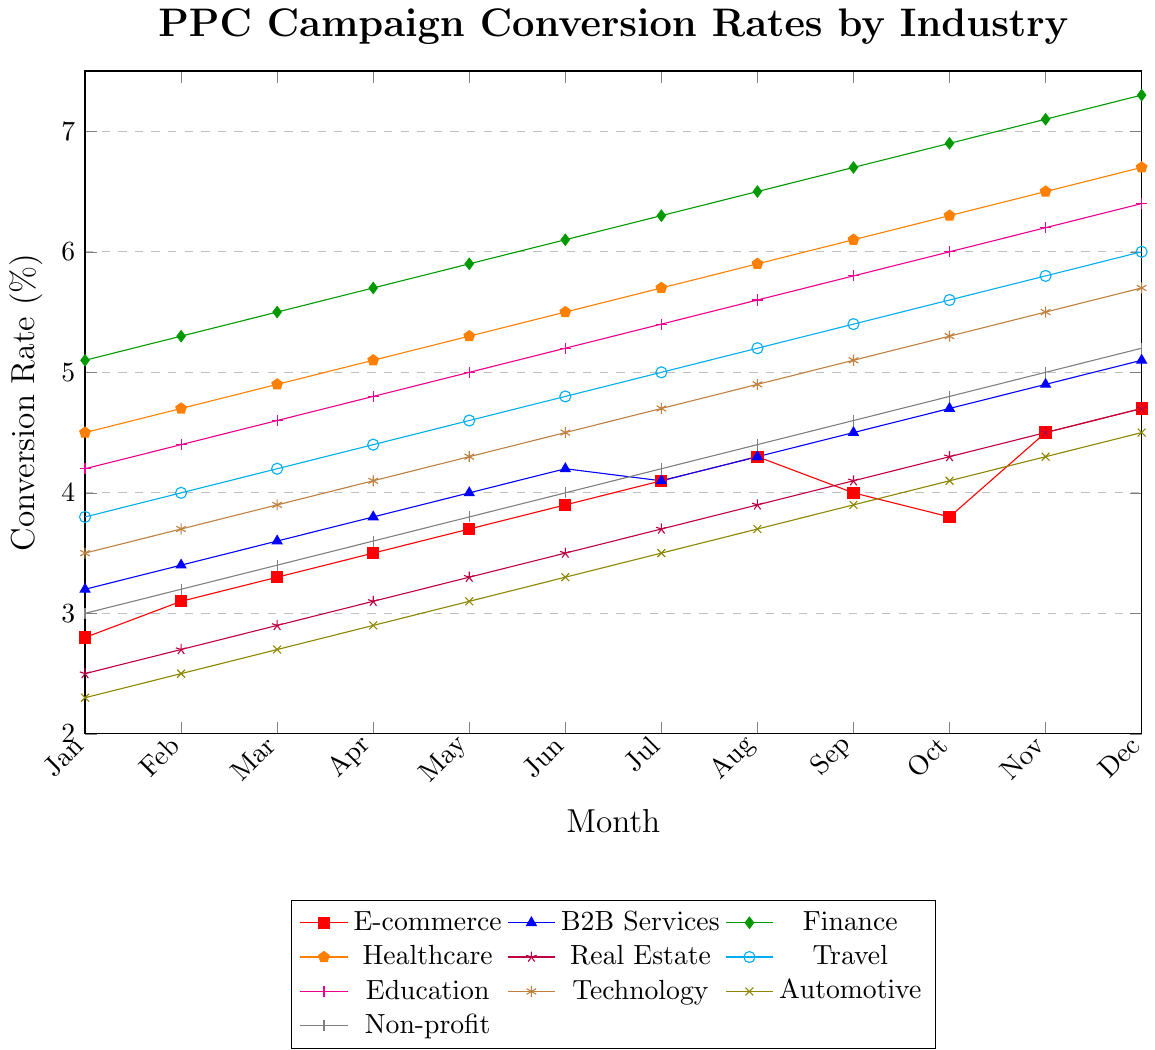Which industry has the highest conversion rate in December? The highest conversion rate can be identified by looking at the conversion rates for each industry in December. Finance has the highest rate with 7.3%.
Answer: Finance How does the conversion rate of the Travel industry in June compare to that in December? Look at the conversion rates for the Travel industry in June (4.8%) and December (6.0%). The rate in December is higher by 1.2 percentage points.
Answer: December is higher by 1.2% Which industries have conversion rates that exceed 6% in December? In December, the industries that have conversion rates above 6% are Finance (7.3%), Healthcare (6.7%), Travel (6.0%), and Education (6.4%).
Answer: Finance, Healthcare, Travel, Education What is the average conversion rate for B2B Services from Jan to Dec? The conversion rates for B2B Services each month are: 3.2, 3.4, 3.6, 3.8, 4.0, 4.2, 4.1, 4.3, 4.5, 4.7, 4.9, 5.1. Summing these gives 50.8, and dividing by 12 months gives an average of 4.23%.
Answer: 4.23% How much did the conversion rate for Healthcare increase from January to December? The conversion rate for Healthcare in January is 4.5%, and in December, it is 6.7%. The increase is 6.7 - 4.5 = 2.2 percentage points.
Answer: 2.2 percentage points Compare the trends of the Non-profit and Automotive industries over the 12 months. Examine the slope of the lines for both industries. Both show an overall positive trend, but the Non-profit industry’s conversion rate increases from 3.0% to 5.2%, while Automotive goes from 2.3% to 4.5%, indicating the Non-profit industry has a steeper increase.
Answer: Non-profit has a steeper increase Which industry had a peak conversion rate drop during the year, and in which month did it occur? A notable drop can be observed for E-commerce: it peaks at 4.3% in August and drops to 4.0% in September, a decrease of 0.3 percentage points, before increasing again.
Answer: E-commerce, September What is the difference in the conversion rates of Real Estate and Technology in December? In December, Real Estate has a conversion rate of 4.7%, while Technology has a conversion rate of 5.7%. The difference is 5.7 - 4.7 = 1 percentage point.
Answer: 1 percentage point By what percentage did the Automotive industry’s conversion rate increase from January to December? The conversion rate for Automotive in January is 2.3%, and in December, it’s 4.5%. The increase is 4.5 - 2.3 = 2.2 percentage points. The percentage increase is (2.2 / 2.3)*100 ≈ 95.65%.
Answer: 95.65% Which industry had the lowest conversion rate in January, and what was it? By comparing the January rates across all industries, Automotive has the lowest conversion rate at 2.3%.
Answer: Automotive, 2.3% 